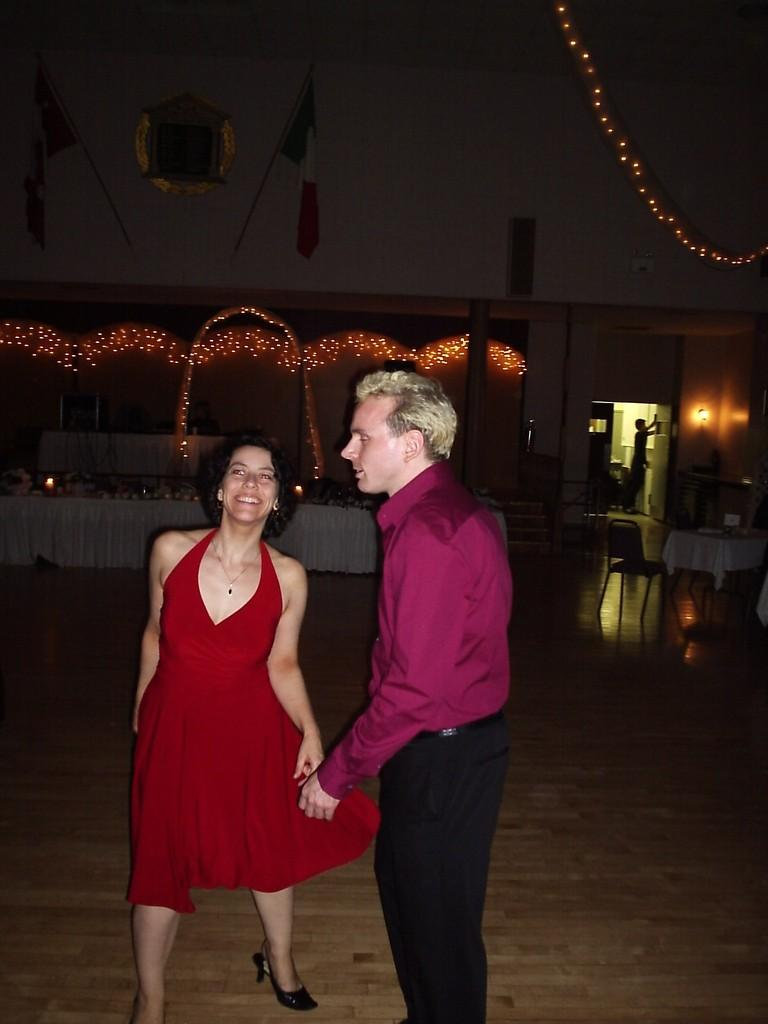What are the people in the image doing? There are people dancing in the image. Can you describe the dancers in the image? There is a man dancing and a woman dancing in the image. What is in the background of the image? There is a table in the background of the image, and it has a white cloth on it. What else can be seen in the image? There are lights visible in the image. What type of quartz can be seen on the table in the image? There is no quartz present on the table in the image; it has a white cloth instead. What kind of cannon is being fired in the image? There is no cannon present in the image; it features people dancing and a table with a white cloth. 